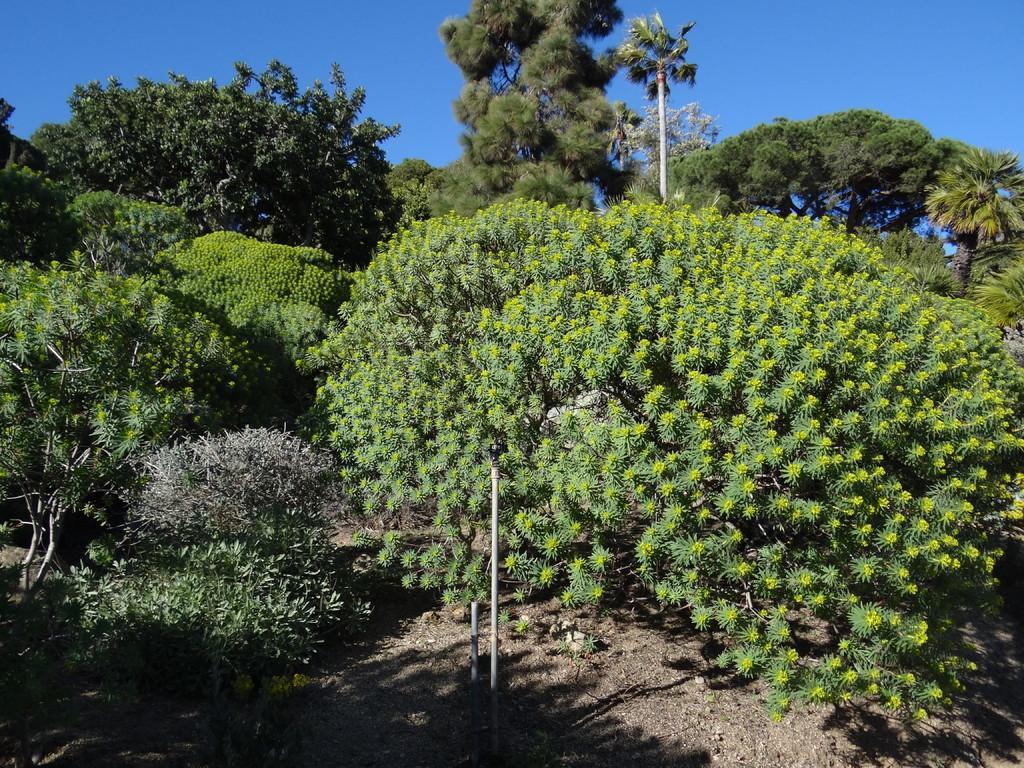How would you summarize this image in a sentence or two? In this image we can see there are trees, poles and sky in the background. 